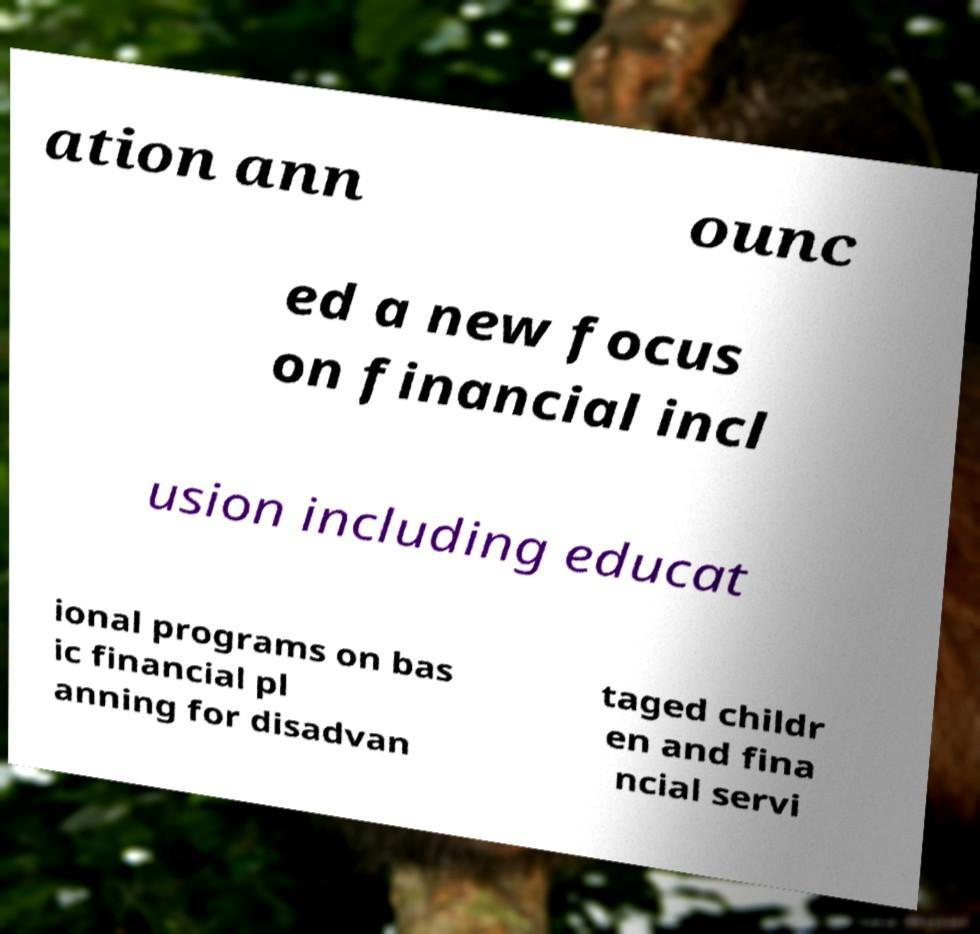What messages or text are displayed in this image? I need them in a readable, typed format. ation ann ounc ed a new focus on financial incl usion including educat ional programs on bas ic financial pl anning for disadvan taged childr en and fina ncial servi 